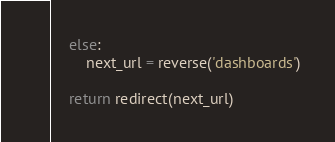<code> <loc_0><loc_0><loc_500><loc_500><_Python_>    else:
        next_url = reverse('dashboards')

    return redirect(next_url)
</code> 